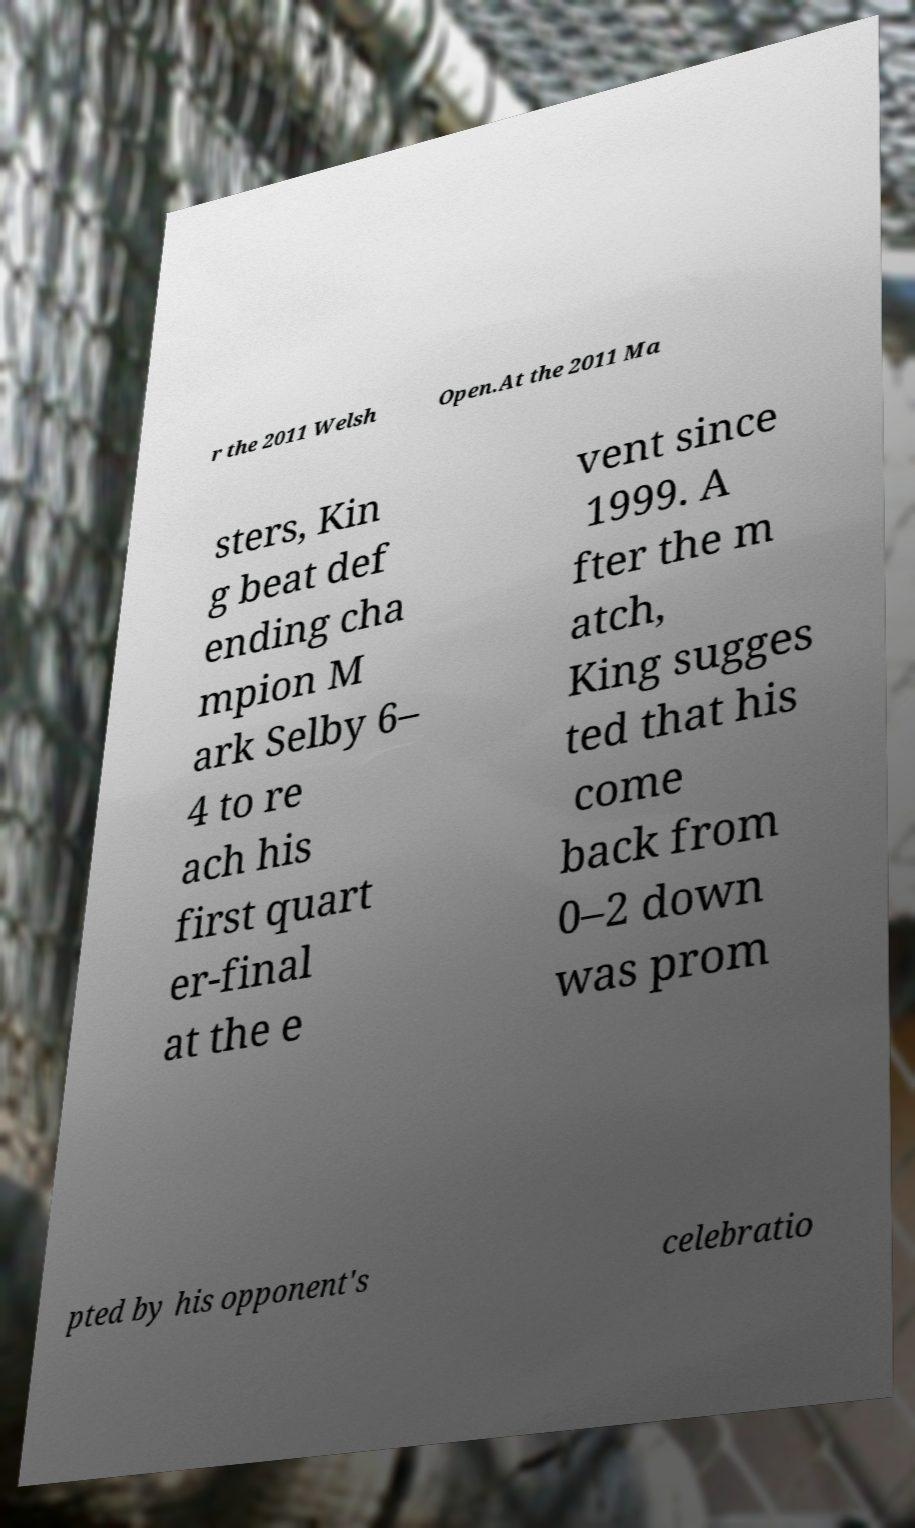What messages or text are displayed in this image? I need them in a readable, typed format. r the 2011 Welsh Open.At the 2011 Ma sters, Kin g beat def ending cha mpion M ark Selby 6– 4 to re ach his first quart er-final at the e vent since 1999. A fter the m atch, King sugges ted that his come back from 0–2 down was prom pted by his opponent's celebratio 